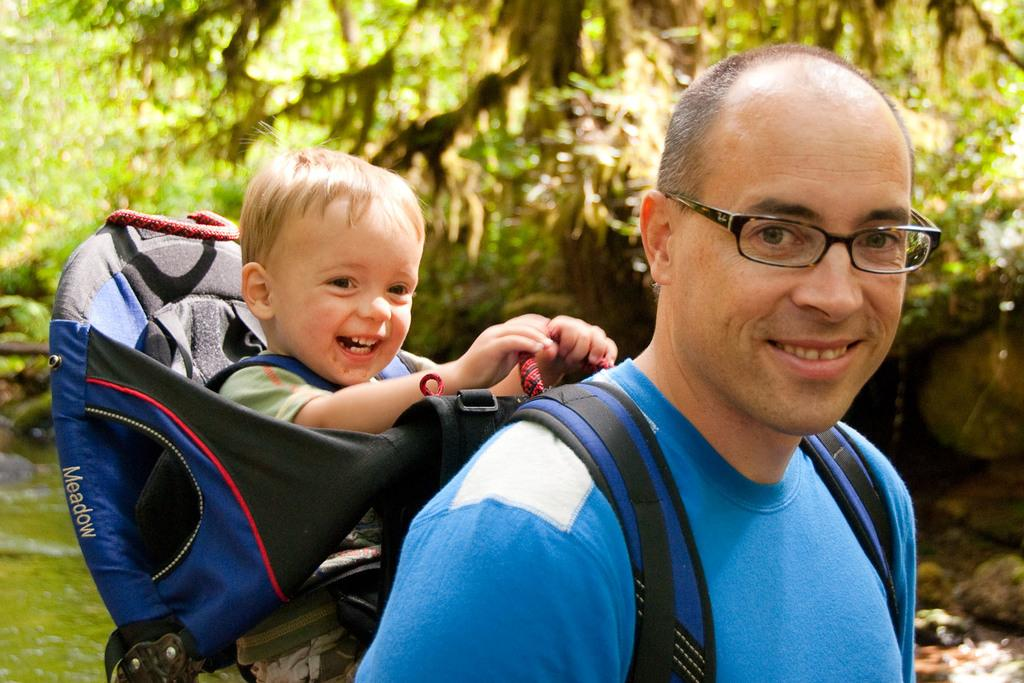Who is the main subject in the image? There is a man in the image. What is the man doing in the image? The man is carrying a boy. How is the boy being carried by the man? The boy is in a babyhug kangaroo pouch. What can be seen in the background of the image? There are trees in the background of the image. How many children are playing in the yard in the image? There is no yard or children playing in the image; it features a man carrying a boy in a babyhug kangaroo pouch. 